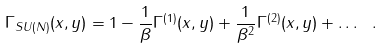<formula> <loc_0><loc_0><loc_500><loc_500>\Gamma _ { S U ( N ) } ( x , y ) = 1 - \frac { 1 } { \beta } \Gamma ^ { ( 1 ) } ( x , y ) + \frac { 1 } { \beta ^ { 2 } } \Gamma ^ { ( 2 ) } ( x , y ) + \dots \ .</formula> 